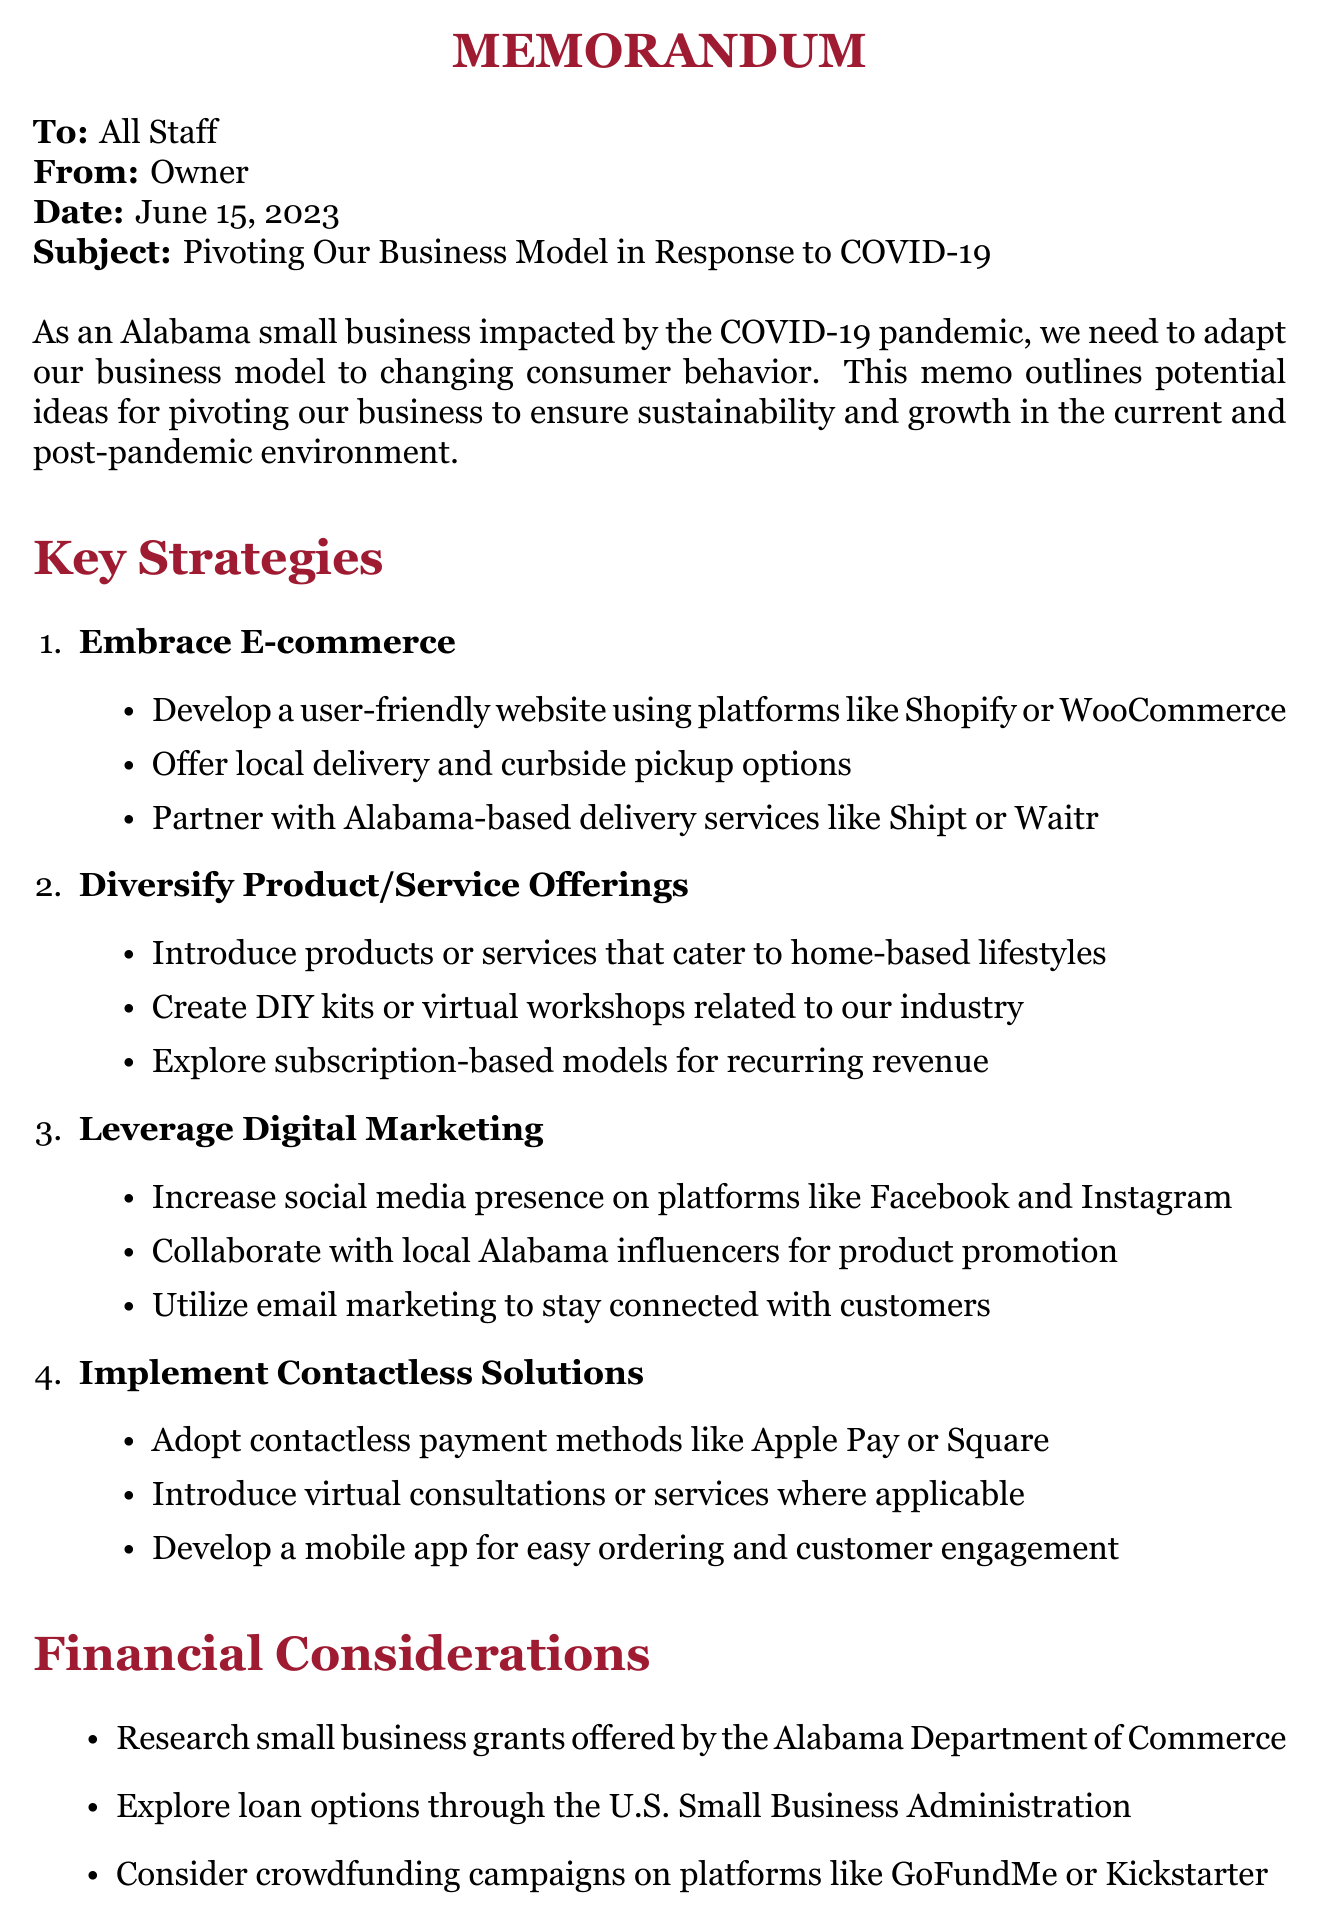What is the date of the memo? The date of the memo is mentioned in the header section.
Answer: June 15, 2023 Who is the memo addressed to? The "To" field in the header section specifies the audience of the memo.
Answer: All Staff What is the title of the first main point? The title of the first main point is listed in the Key Strategies section.
Answer: Embrace E-commerce What is one suggested method for digital marketing? The document lists several strategies under the Leverage Digital Marketing section.
Answer: Increase social media presence What type of solutions should be implemented for contactless transactions? The Implement Contactless Solutions section provides specific actions to adopt contactless technology.
Answer: Contactless payment methods Which local resource is mentioned for free business consulting? The Local Resources section names organizations that can provide assistance.
Answer: Alabama Small Business Development Center How many main strategies are listed in the document? The total number of strategies can be counted from the Key Strategies section.
Answer: Four What kind of workshops does the memo suggest creating? The Diversify Product/Service Offerings section recommends relevant content for the target audience.
Answer: Virtual workshops What is the purpose of this memo? The introductory section outlines the main objective of writing the memo.
Answer: Adapt our business model 